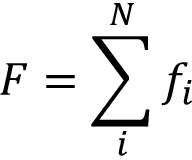<formula> <loc_0><loc_0><loc_500><loc_500>F = \sum _ { i } ^ { N } f _ { i }</formula> 